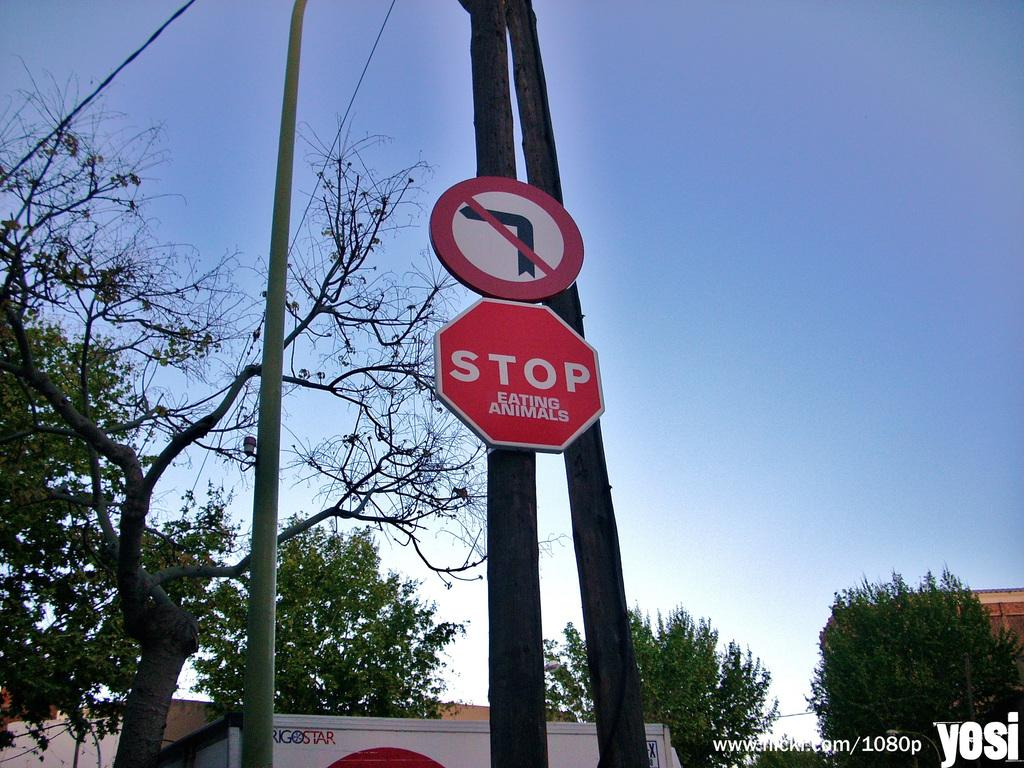<image>
Provide a brief description of the given image. A red and white stop sign has a sticker that reads eating animals below it. 